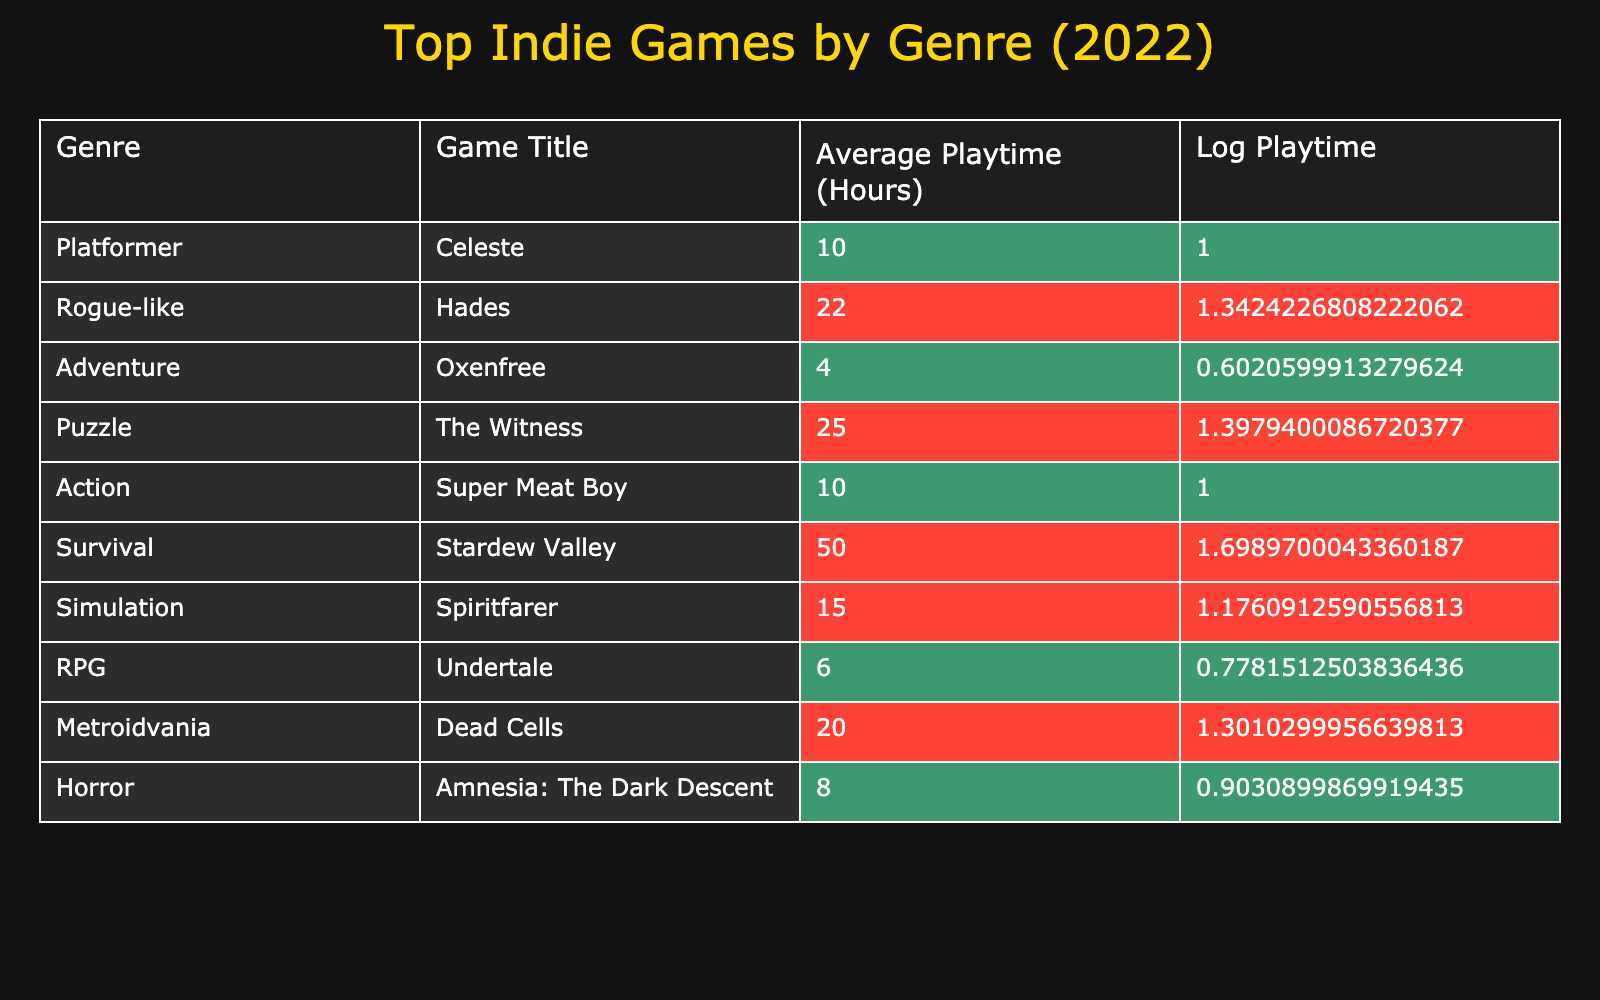What is the average playtime of the game "Hades"? The average playtime listed for "Hades" in the table is 22 hours.
Answer: 22 hours Which game has the longest average playtime? By checking the "Average Playtime (Hours)" column, "Stardew Valley" has the longest average playtime at 50 hours.
Answer: 50 hours Are there any horror games listed in the table? Yes, "Amnesia: The Dark Descent" is the horror game listed in the table.
Answer: Yes What is the total average playtime of all the platformer games? The only platformer listed is "Celeste," with an average playtime of 10 hours. Therefore, the total average playtime for platformers is 10 hours.
Answer: 10 hours How does the average playtime of "Undertale" compare to "Oxenfree"? "Undertale" has an average playtime of 6 hours, while "Oxenfree" has an average playtime of 4 hours, making "Undertale" 2 hours longer.
Answer: 2 hours longer What is the average playtime for action and adventure games combined? The average playtime for "Super Meat Boy" (action) is 10 hours and for "Oxenfree" (adventure) is 4 hours. The total is 10 + 4 = 14. Since there are two games, the average is 14/2 = 7 hours.
Answer: 7 hours Is the average playtime of "The Witness" higher than that of "Spiritfarer"? "The Witness" has an average playtime of 25 hours, while "Spiritfarer" has 15 hours. Since 25 is greater than 15, the average playtime of "The Witness" is indeed higher.
Answer: Yes Which genre has the highest average playtime and what is it? The genre with the highest average playtime is Survival, with "Stardew Valley" averaging 50 hours.
Answer: Survival, 50 hours How many games have an average playtime over 20 hours? Checking the table, "Hades" (22 hours), "The Witness" (25 hours), and "Stardew Valley" (50 hours) all exceed 20 hours, totaling 3 games.
Answer: 3 games 